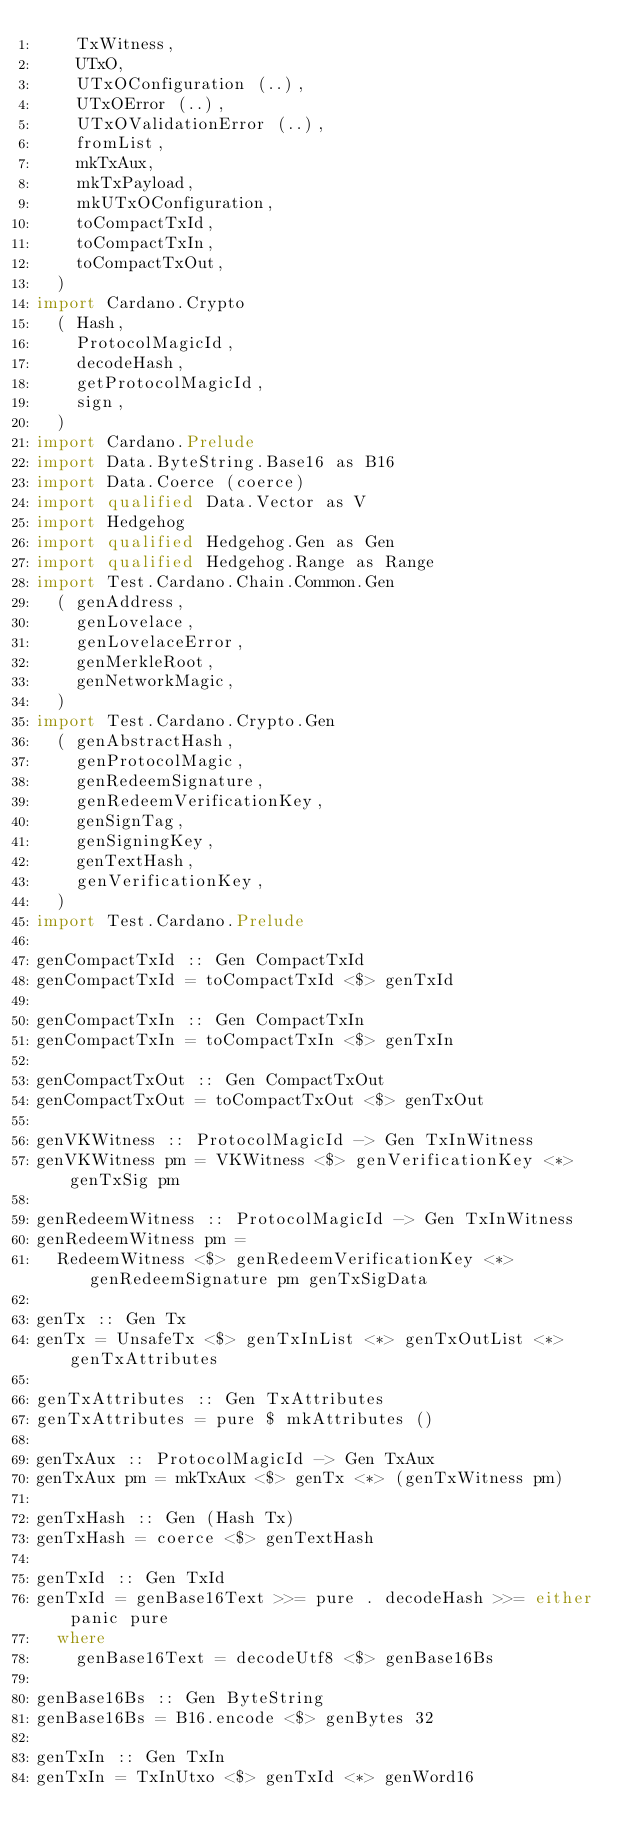<code> <loc_0><loc_0><loc_500><loc_500><_Haskell_>    TxWitness,
    UTxO,
    UTxOConfiguration (..),
    UTxOError (..),
    UTxOValidationError (..),
    fromList,
    mkTxAux,
    mkTxPayload,
    mkUTxOConfiguration,
    toCompactTxId,
    toCompactTxIn,
    toCompactTxOut,
  )
import Cardano.Crypto
  ( Hash,
    ProtocolMagicId,
    decodeHash,
    getProtocolMagicId,
    sign,
  )
import Cardano.Prelude
import Data.ByteString.Base16 as B16
import Data.Coerce (coerce)
import qualified Data.Vector as V
import Hedgehog
import qualified Hedgehog.Gen as Gen
import qualified Hedgehog.Range as Range
import Test.Cardano.Chain.Common.Gen
  ( genAddress,
    genLovelace,
    genLovelaceError,
    genMerkleRoot,
    genNetworkMagic,
  )
import Test.Cardano.Crypto.Gen
  ( genAbstractHash,
    genProtocolMagic,
    genRedeemSignature,
    genRedeemVerificationKey,
    genSignTag,
    genSigningKey,
    genTextHash,
    genVerificationKey,
  )
import Test.Cardano.Prelude

genCompactTxId :: Gen CompactTxId
genCompactTxId = toCompactTxId <$> genTxId

genCompactTxIn :: Gen CompactTxIn
genCompactTxIn = toCompactTxIn <$> genTxIn

genCompactTxOut :: Gen CompactTxOut
genCompactTxOut = toCompactTxOut <$> genTxOut

genVKWitness :: ProtocolMagicId -> Gen TxInWitness
genVKWitness pm = VKWitness <$> genVerificationKey <*> genTxSig pm

genRedeemWitness :: ProtocolMagicId -> Gen TxInWitness
genRedeemWitness pm =
  RedeemWitness <$> genRedeemVerificationKey <*> genRedeemSignature pm genTxSigData

genTx :: Gen Tx
genTx = UnsafeTx <$> genTxInList <*> genTxOutList <*> genTxAttributes

genTxAttributes :: Gen TxAttributes
genTxAttributes = pure $ mkAttributes ()

genTxAux :: ProtocolMagicId -> Gen TxAux
genTxAux pm = mkTxAux <$> genTx <*> (genTxWitness pm)

genTxHash :: Gen (Hash Tx)
genTxHash = coerce <$> genTextHash

genTxId :: Gen TxId
genTxId = genBase16Text >>= pure . decodeHash >>= either panic pure
  where
    genBase16Text = decodeUtf8 <$> genBase16Bs

genBase16Bs :: Gen ByteString
genBase16Bs = B16.encode <$> genBytes 32

genTxIn :: Gen TxIn
genTxIn = TxInUtxo <$> genTxId <*> genWord16
</code> 